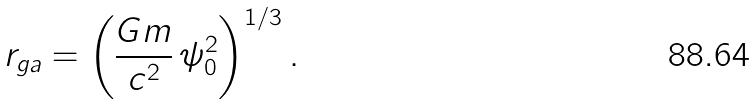<formula> <loc_0><loc_0><loc_500><loc_500>r _ { g a } = \left ( \frac { G m } { c ^ { 2 } } \, \psi _ { 0 } ^ { 2 } \right ) ^ { 1 / 3 } .</formula> 